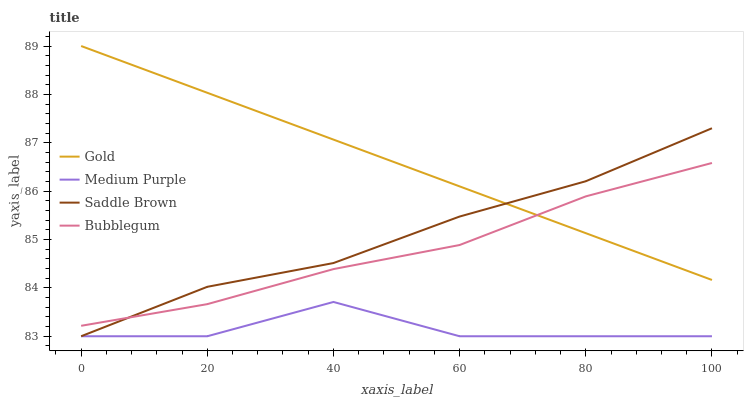Does Medium Purple have the minimum area under the curve?
Answer yes or no. Yes. Does Gold have the maximum area under the curve?
Answer yes or no. Yes. Does Bubblegum have the minimum area under the curve?
Answer yes or no. No. Does Bubblegum have the maximum area under the curve?
Answer yes or no. No. Is Gold the smoothest?
Answer yes or no. Yes. Is Medium Purple the roughest?
Answer yes or no. Yes. Is Bubblegum the smoothest?
Answer yes or no. No. Is Bubblegum the roughest?
Answer yes or no. No. Does Medium Purple have the lowest value?
Answer yes or no. Yes. Does Bubblegum have the lowest value?
Answer yes or no. No. Does Gold have the highest value?
Answer yes or no. Yes. Does Bubblegum have the highest value?
Answer yes or no. No. Is Medium Purple less than Bubblegum?
Answer yes or no. Yes. Is Bubblegum greater than Medium Purple?
Answer yes or no. Yes. Does Gold intersect Saddle Brown?
Answer yes or no. Yes. Is Gold less than Saddle Brown?
Answer yes or no. No. Is Gold greater than Saddle Brown?
Answer yes or no. No. Does Medium Purple intersect Bubblegum?
Answer yes or no. No. 